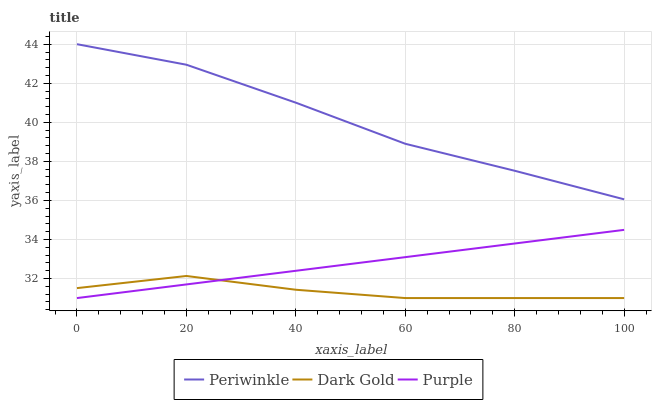Does Dark Gold have the minimum area under the curve?
Answer yes or no. Yes. Does Periwinkle have the maximum area under the curve?
Answer yes or no. Yes. Does Periwinkle have the minimum area under the curve?
Answer yes or no. No. Does Dark Gold have the maximum area under the curve?
Answer yes or no. No. Is Purple the smoothest?
Answer yes or no. Yes. Is Dark Gold the roughest?
Answer yes or no. Yes. Is Periwinkle the smoothest?
Answer yes or no. No. Is Periwinkle the roughest?
Answer yes or no. No. Does Purple have the lowest value?
Answer yes or no. Yes. Does Periwinkle have the lowest value?
Answer yes or no. No. Does Periwinkle have the highest value?
Answer yes or no. Yes. Does Dark Gold have the highest value?
Answer yes or no. No. Is Dark Gold less than Periwinkle?
Answer yes or no. Yes. Is Periwinkle greater than Dark Gold?
Answer yes or no. Yes. Does Purple intersect Dark Gold?
Answer yes or no. Yes. Is Purple less than Dark Gold?
Answer yes or no. No. Is Purple greater than Dark Gold?
Answer yes or no. No. Does Dark Gold intersect Periwinkle?
Answer yes or no. No. 